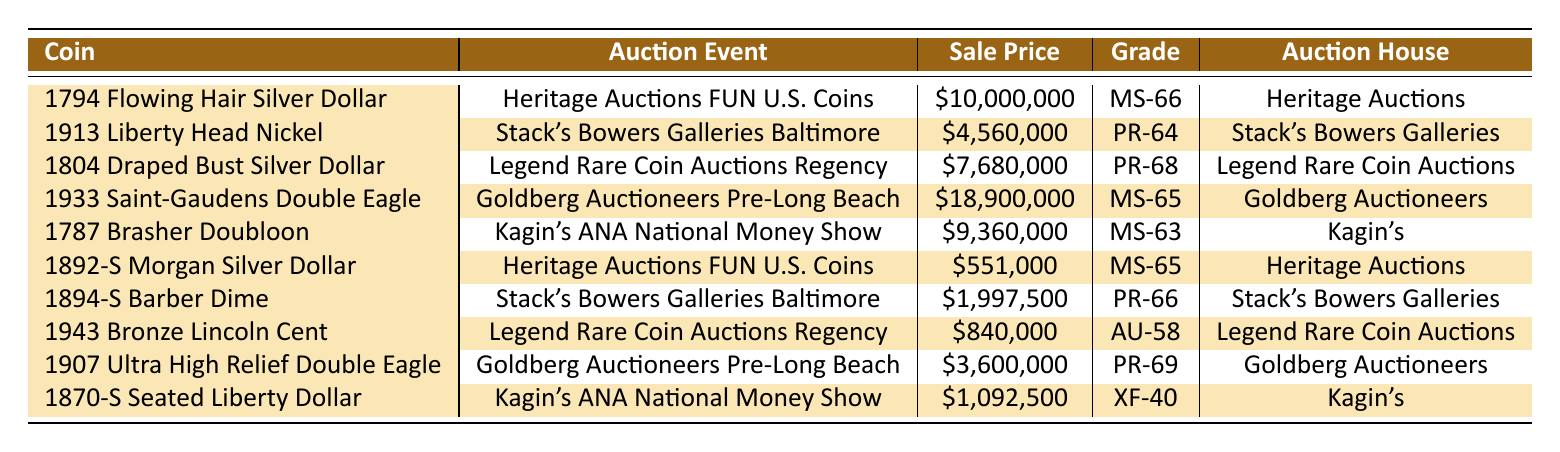What is the sale price of the 1933 Saint-Gaudens Double Eagle? The sale price of the 1933 Saint-Gaudens Double Eagle is listed directly in the table. It shows \$18,900,000.
Answer: \$18,900,000 Which coin received the highest grade? Looking at the grade column, the highest grade recorded is PR-69 for the 1907 Ultra High Relief Double Eagle.
Answer: PR-69 What is the total sale price of coins sold at Heritage Auctions? The sale prices for coins from Heritage Auctions are \$10,000,000 (1794 Flowing Hair Silver Dollar) and \$551,000 (1892-S Morgan Silver Dollar). Adding these gives: \$10,000,000 + \$551,000 = \$10,551,000.
Answer: \$10,551,000 Is the sale price of the 1913 Liberty Head Nickel greater than that of the 1892-S Morgan Silver Dollar? The sale price of the 1913 Liberty Head Nickel is \$4,560,000 while the 1892-S Morgan Silver Dollar is \$551,000. Comparing the two shows that \$4,560,000 is greater than \$551,000.
Answer: Yes What is the average sale price of coins auctioned by Stack's Bowers Galleries? The sale prices from Stack's Bowers Galleries are \$4,560,000 (1913 Liberty Head Nickel) and \$1,997,500 (1894-S Barber Dime). The average is computed by adding these two prices: \$4,560,000 + \$1,997,500 = \$6,557,500, then dividing by the number of coins: \$6,557,500 / 2 = \$3,278,750.
Answer: \$3,278,750 How many auction events involve Heritage Auctions? The table displays two entries corresponding to Heritage Auctions: the 1794 Flowing Hair Silver Dollar and the 1892-S Morgan Silver Dollar. Therefore, there are two events involving Heritage Auctions.
Answer: 2 Which coin had the lowest sale price, and what is that price? Reviewing the sale prices, the lowest price is \$551,000 for the 1892-S Morgan Silver Dollar.
Answer: \$551,000 What is the difference in sale price between the 1804 Draped Bust Silver Dollar and the 1943 Bronze Lincoln Cent? The sale price of the 1804 Draped Bust Silver Dollar is \$7,680,000 and that of the 1943 Bronze Lincoln Cent is \$840,000. The difference is calculated as \$7,680,000 - \$840,000 = \$6,840,000.
Answer: \$6,840,000 How many coins were sold at auction for more than \$9 million? The table lists three coins above \$9 million: the 1794 Flowing Hair Silver Dollar (\$10,000,000), the 1933 Saint-Gaudens Double Eagle (\$18,900,000), and the 1787 Brasher Doubloon (\$9,360,000). Thus, the total count is three.
Answer: 3 Which auction event had the highest sale price recorded? The highest sale price recorded in the table is for the 1933 Saint-Gaudens Double Eagle, which was auctioned at the Goldberg Auctioneers Pre-Long Beach Expo for \$18,900,000. Hence, that auction event had the highest price.
Answer: Goldberg Auctioneers Pre-Long Beach Expo 